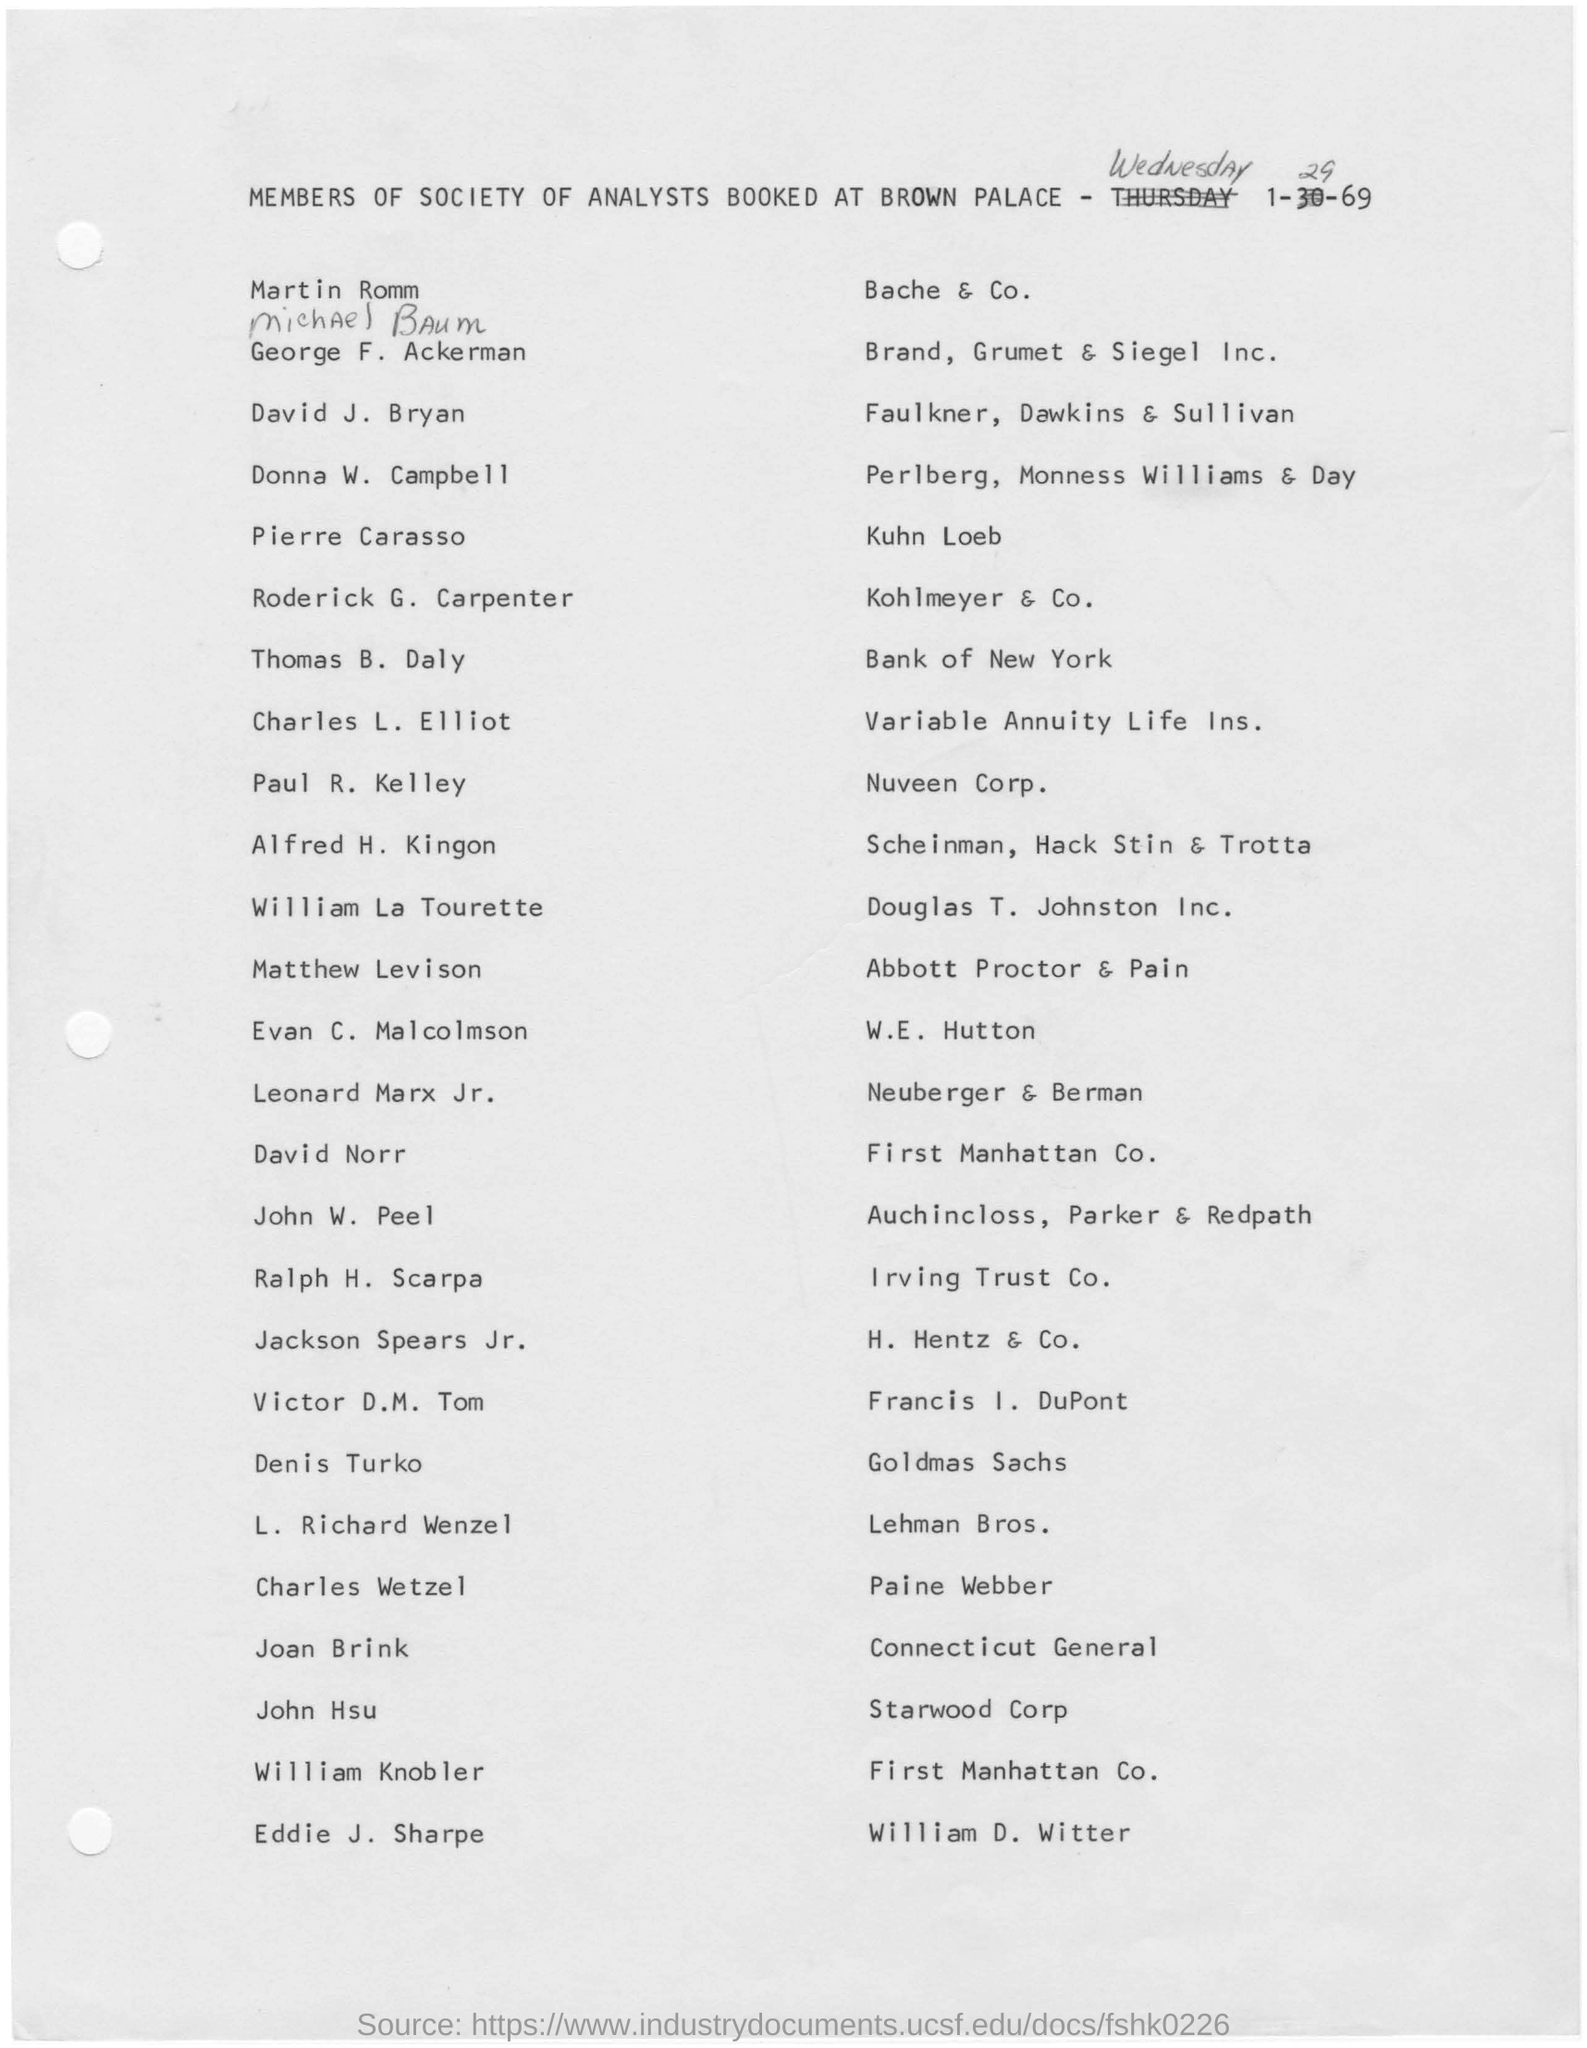Specify some key components in this picture. Thomas B. Daly from the Bank of New York is representing. The document was drafted on Wednesday. David Norr is from First Manhattan Company, a renowned investment firm with a global reach and a commitment to excellence. 